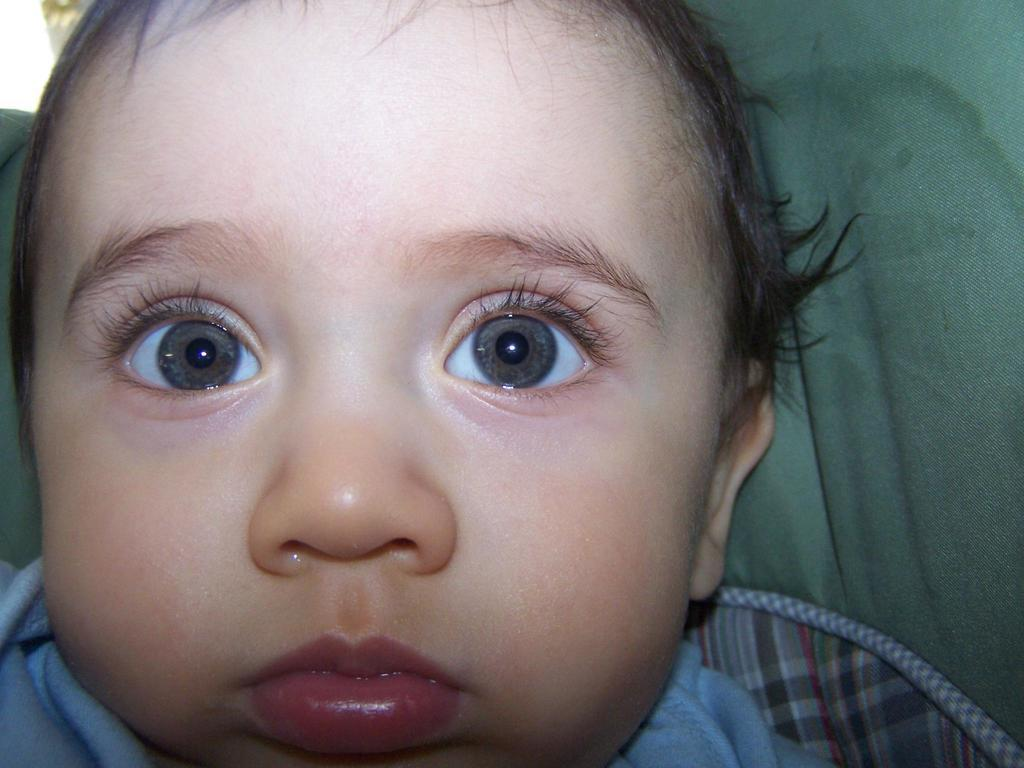What is the main subject of the image? The main subject of the image is a kid's face. Can you describe anything in the background of the image? Yes, there is a cloth in the background of the image. What type of mint plant can be seen growing in the image? There is no mint plant present in the image; it features a kid's face and a cloth in the background. What shape is the machine in the image? There is no machine present in the image. 